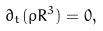Convert formula to latex. <formula><loc_0><loc_0><loc_500><loc_500>\partial _ { t } ( \rho R ^ { 3 } ) = 0 ,</formula> 